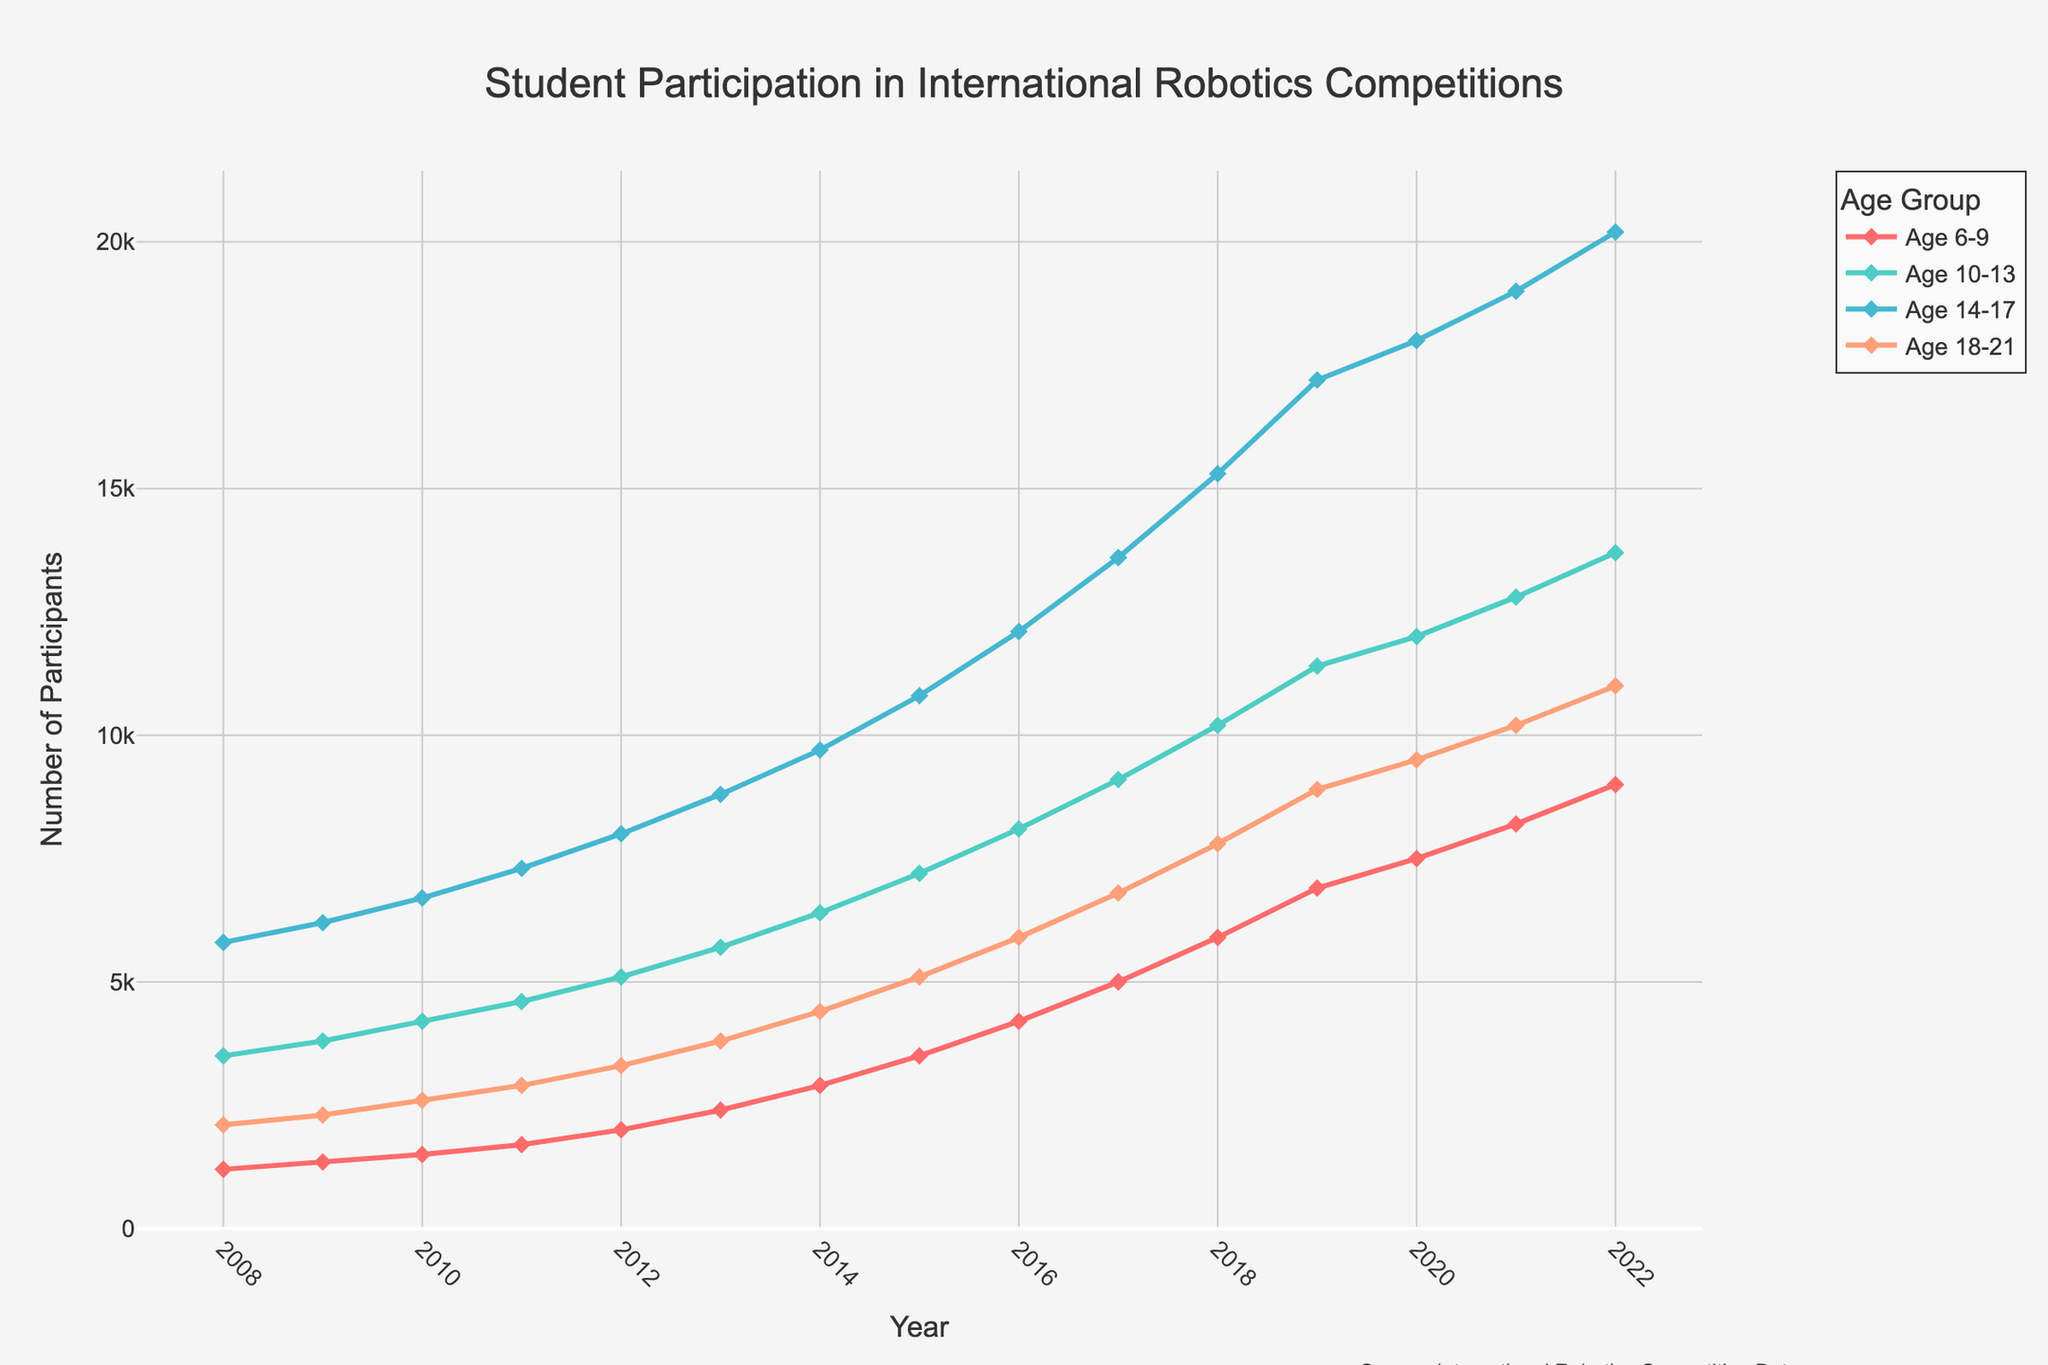How has the number of students aged 6-9 participating in international robotics competitions changed from 2008 to 2022? To find the change in the number of students aged 6-9, we subtract the number in 2008 from the number in 2022: 9000 - 1200.
Answer: 7800 In which year did the age group 14-17 first surpass 10,000 participants? We look at the values for the age group 14-17 to identify when it first exceeded 10,000 participants. In 2015, this number is 10,800.
Answer: 2015 Compare the trends for age groups 10-13 and 18-21 over the 15-year period. Which age group shows a steeper increase? To determine the steepness, we compare the numerical increase for both age groups over 15 years. For 10-13, the increase is from 3500 to 13700 and for 18-21, it is from 2100 to 11000. The increase for 10-13 is larger.
Answer: Age 10-13 What is the average number of participants in the age group 18-21 over the 15-year period? We sum the participant numbers for age 18-21 from 2008 to 2022 and divide by 15: (2100 + 2300 + 2600 + 2900 + 3300 + 3800 + 4400 + 5100 + 5900 + 6800 + 7800 + 8900 + 9500 + 10200 + 11000) / 15.
Answer: 5780 Which age group had the highest number of participants in 2022? We compare the numbers for all age groups in 2022. Age 14-17 has the highest with 20,200 participants.
Answer: Age 14-17 What is the total increase in participants across all age groups from 2008 to 2022? We calculate the total participants for each year and find the difference: (9000 + 13700 + 20200 + 11000) - (1200 + 3500 + 5800 + 2100).
Answer: 32000 How does the participant growth rate for age group 6-9 between 2017 and 2022 compare to the growth rate for age group 18-21 over the same period? We calculate the growth for both: (9000 - 5000) for 6-9, and (11000 - 6800) for 18-21. The growth for 6-9 (4000) is less than the growth for 18-21 (4200).
Answer: Age 18-21 has a higher growth rate What's the difference in the number of participants aged 10-13 between the highest and the lowest years? The highest is 13700 in 2022, and the lowest is 3500 in 2008. The difference is 13700 - 3500.
Answer: 10200 What color represents the age group 14-17 in the plot, and what does this indicate about their trend? The age group 14-17 is represented by the color blue, and the steadily increasing line indicates a consistent rise in participation over the years.
Answer: Blue, steadily increasing Which year saw the smallest increase in participants for the age group 10-13 compared to the previous year? We compare the yearly increase values for age 10-13 and identify the smallest increase: the increase from 2020 to 2021 is the smallest (800).
Answer: 2021 